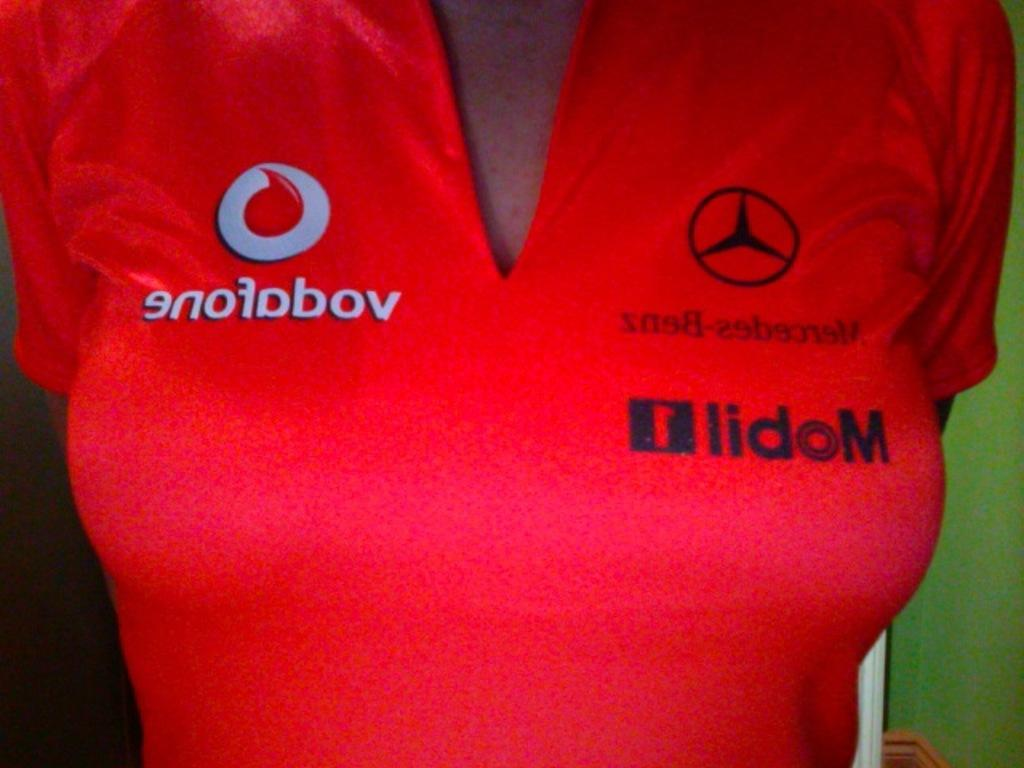<image>
Share a concise interpretation of the image provided. A red v-neck t-shirt with Mobil and Mercedes-Benz logos on it. 